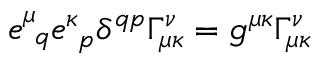Convert formula to latex. <formula><loc_0><loc_0><loc_500><loc_500>e _ { q } ^ { \mu } e _ { p } ^ { \kappa } \delta ^ { q p } \Gamma _ { \mu \kappa } ^ { \nu } = g ^ { \mu \kappa } \Gamma _ { \mu \kappa } ^ { \nu }</formula> 